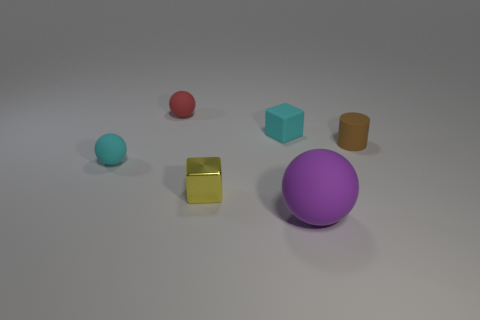Subtract all tiny balls. How many balls are left? 1 Add 3 large yellow metallic cylinders. How many objects exist? 9 Subtract all red balls. How many balls are left? 2 Subtract all cylinders. How many objects are left? 5 Subtract 0 gray cubes. How many objects are left? 6 Subtract 1 blocks. How many blocks are left? 1 Subtract all green spheres. Subtract all green cylinders. How many spheres are left? 3 Subtract all green spheres. How many cyan cubes are left? 1 Subtract all tiny matte cylinders. Subtract all tiny red spheres. How many objects are left? 4 Add 6 yellow things. How many yellow things are left? 7 